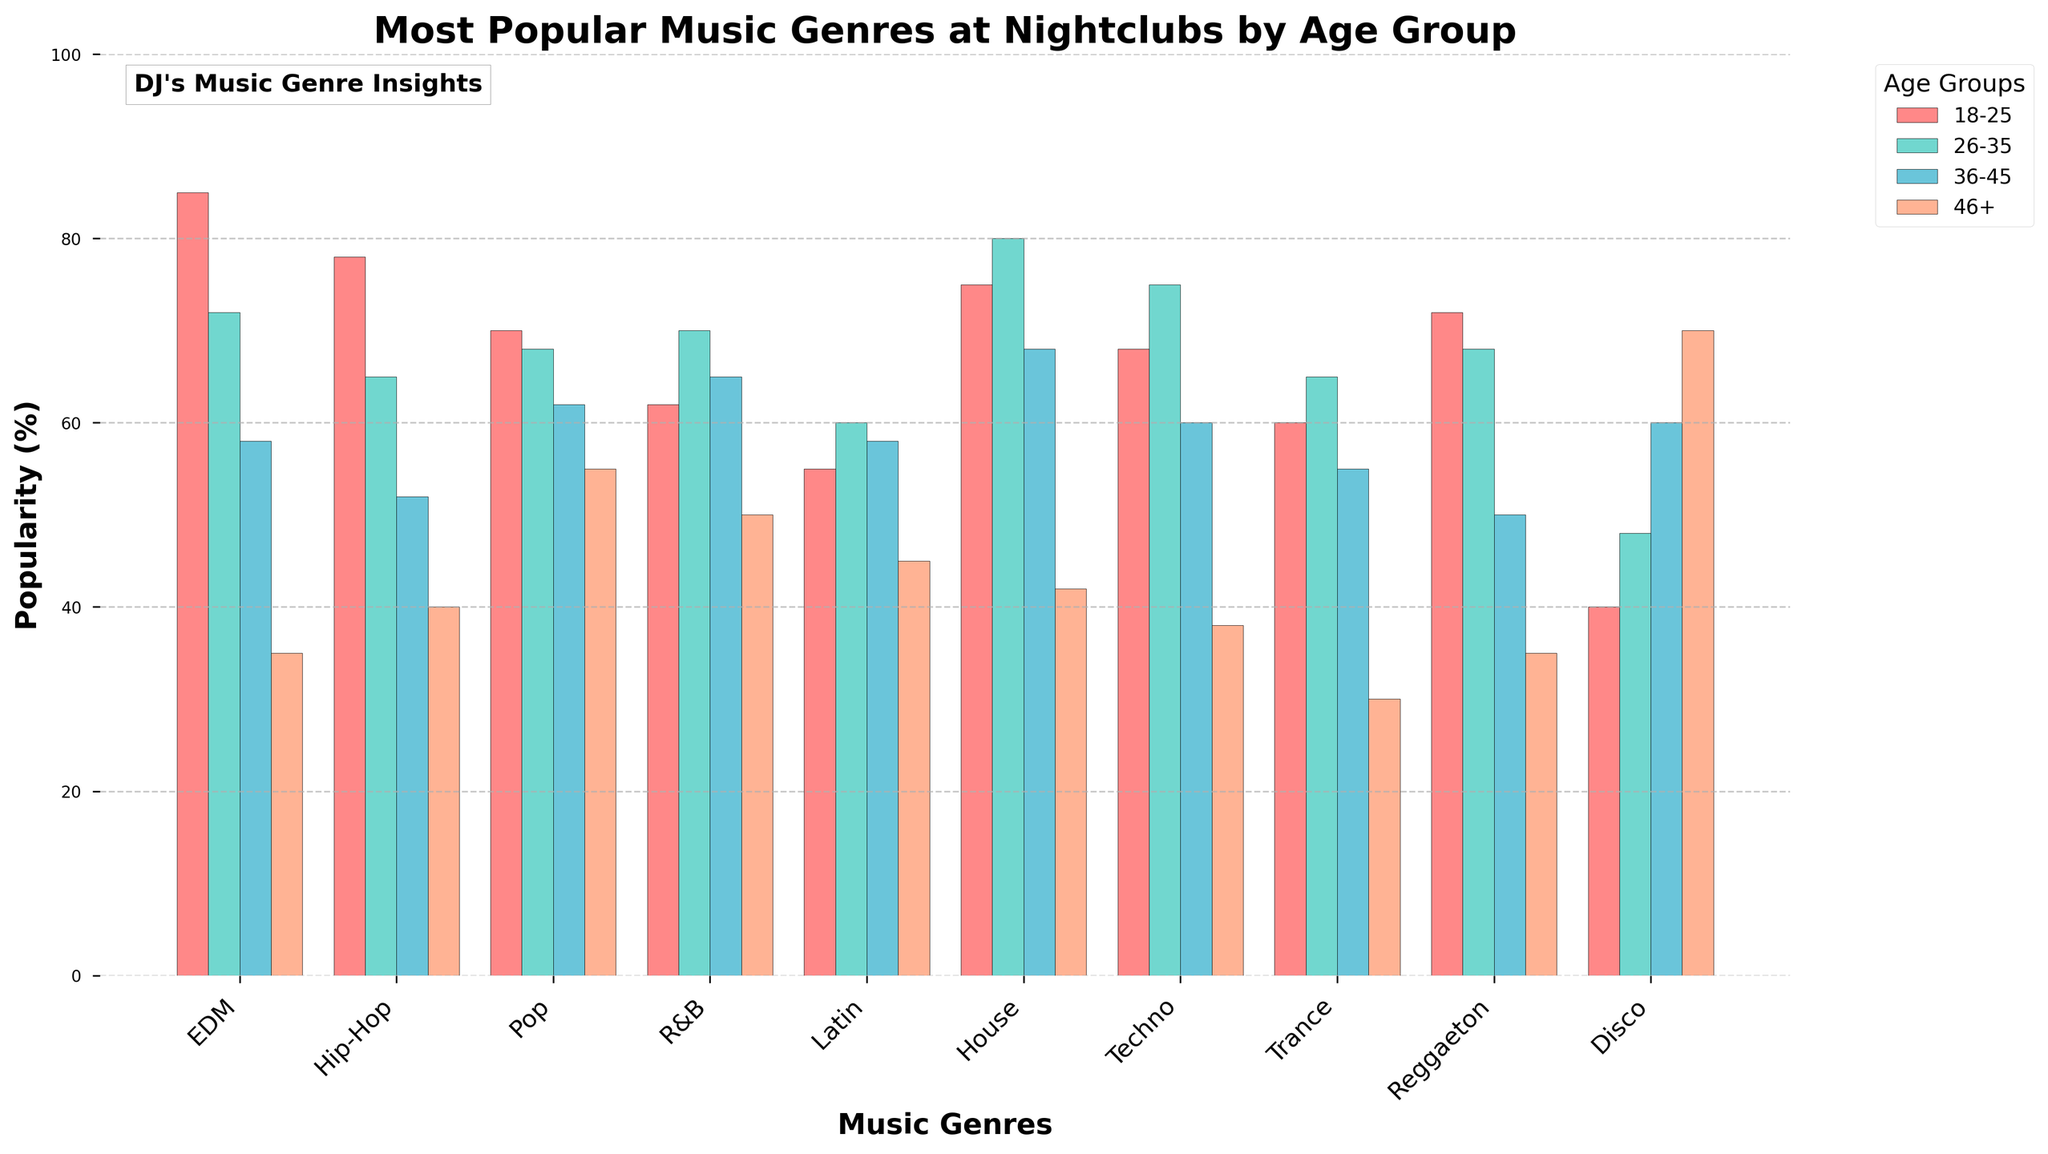Which genre is most popular among the 18-25 age group? The bar corresponding to the 18-25 age group is the highest in the EDM category.
Answer: EDM How does the popularity of Disco among the 46+ age group compare to its popularity among the 18-25 age group? The height of the bar for Disco is much taller in the 46+ age group compared to the 18-25 age group, indicating it is more popular among the older age group.
Answer: More popular Which age group shows the highest popularity for House music? The bar for the age group 26-35 is the tallest among all age groups in the House music category.
Answer: 26-35 What is the difference in popularity between Hip-Hop and Techno for the 26-35 age group? For the 26-35 age group, the Hip-Hop bar is at 65%, and the Techno bar is at 75%, so the difference is 75% - 65% = 10%.
Answer: 10% Which genre has the most evenly distributed popularity across all age groups? Pop music has bars of relatively similar height across all age groups, indicating it is evenly liked.
Answer: Pop How does the popularity of Latin music change from the 18-25 group to the 46+ group? The height of the bars for Latin music decreases from 55% in the 18-25 group to 45% in the 46+ group.
Answer: Decreases What can you infer about the trend in popularity of R&B music from 18-25 to 46+? The bar heights for R&B music increase from 62% in the 18-25 group to 70% in the 26-35 group, then slightly decrease but still remain relatively high among older age groups.
Answer: Stable trend with a peak What is the sum of the popularity percentages of Trance music across all age groups? Sum the popularity percentages for Trance music: 60% (18-25) + 65% (26-35) + 55% (36-45) + 30% (46+) = 210%.
Answer: 210% Which genre has the largest gap in popularity between the 36-45 and 46+ age groups? Disco shows a large gap with popularity being 60% among the 36-45 group and 70% in the 46+ group.
Answer: Disco Between EDM and Reggaeton, which genre is more popular in the 36-45 age group? The bar for EDM is higher than the bar for Reggaeton in the 36-45 age group, indicating EDM is more popular.
Answer: EDM 